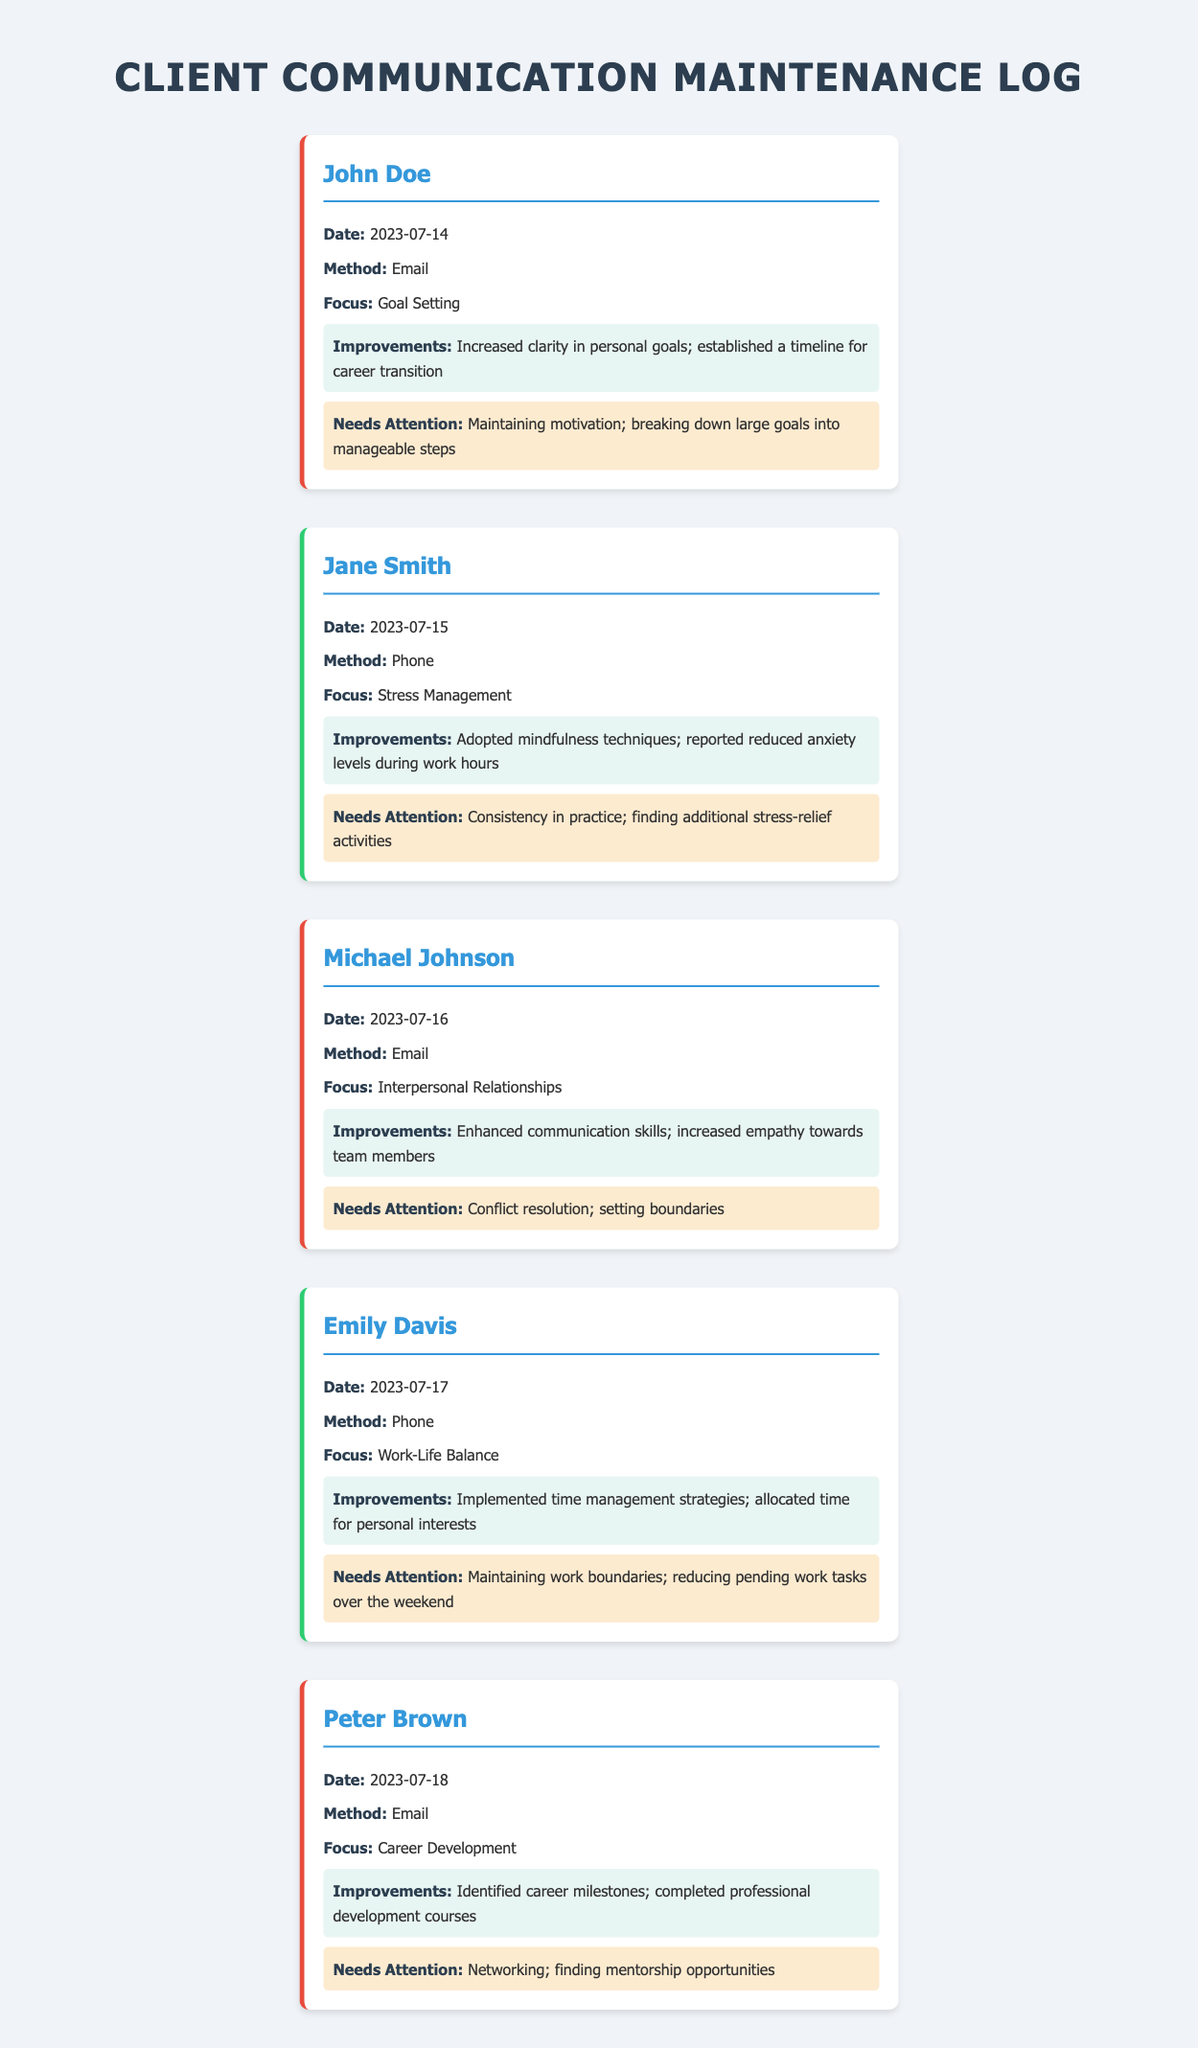What is the date of John Doe's communication? The date of John Doe's communication is listed in the log entry for him.
Answer: 2023-07-14 What method was used to communicate with Emily Davis? The method of communication for Emily Davis is noted in her log entry.
Answer: Phone What was the primary focus of Michael Johnson's conversation? The focus of Michael Johnson's conversation is specified in the log entry about him.
Answer: Interpersonal Relationships What improvement did Jane Smith report during her sessions? The improvements reported by Jane Smith are detailed in her log entry.
Answer: Adopted mindfulness techniques Which area does Peter Brown need further attention in? The areas needing attention for Peter Brown are provided in his log entry.
Answer: Networking How many clients are mentioned in the log? The total number of clients can be counted from the entries in the log.
Answer: Five What is the main focus of the most recent communication recorded? The focus of the most recent communication is found in the last entry of the log.
Answer: Career Development Which improvement did John Doe achieve? The improvements noted in the log entry for John Doe explain what he has achieved.
Answer: Increased clarity in personal goals Who had a focus on stress management? The client's name focusing on stress management can be found in the log entries.
Answer: Jane Smith What color represents email communications in the log? The color style for email communications is indicated in the log's design.
Answer: Red 